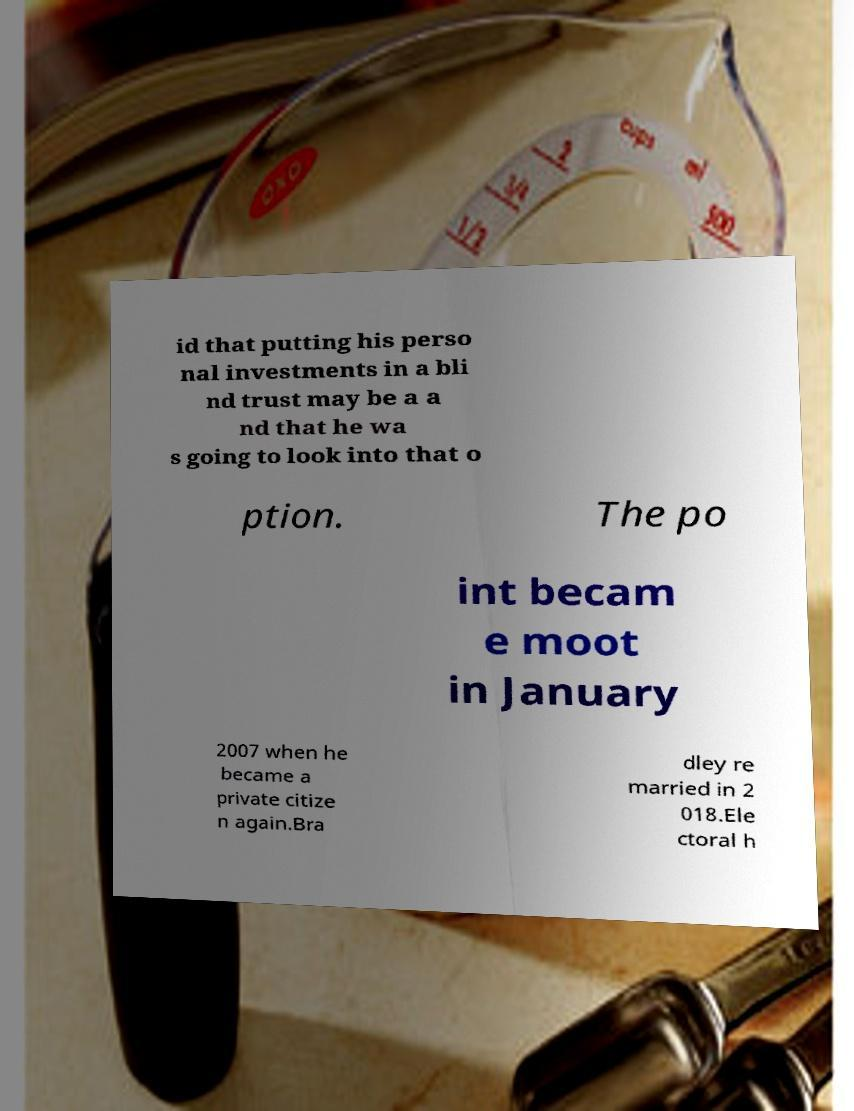There's text embedded in this image that I need extracted. Can you transcribe it verbatim? id that putting his perso nal investments in a bli nd trust may be a a nd that he wa s going to look into that o ption. The po int becam e moot in January 2007 when he became a private citize n again.Bra dley re married in 2 018.Ele ctoral h 